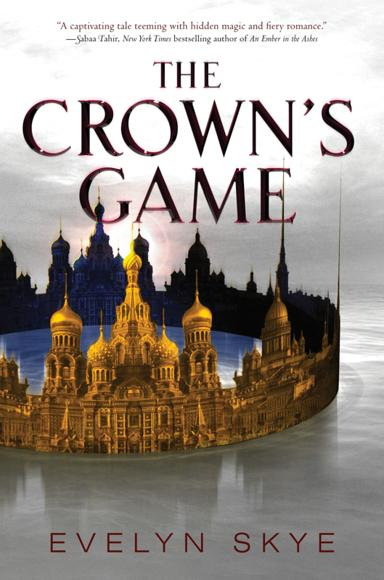Who is the author of the quote recommending the book? The recommendation for 'The Crown's Game' comes from Sabaa Tahir, acclaimed for her New York Times bestselling series 'An Ember in the Ashes.' Her endorsement highlights the book's appeal to fans of rich narratives and deep, imaginative worlds. 